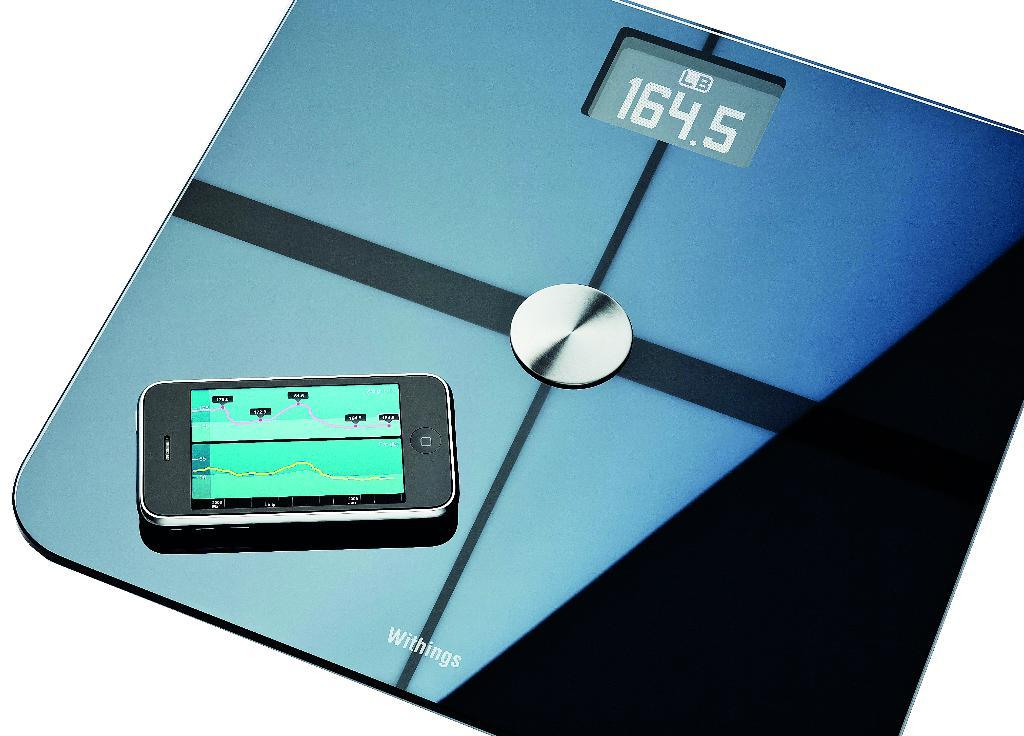Provide a one-sentence caption for the provided image. A digital scale with a cell phone on it and a display of 164.5. 